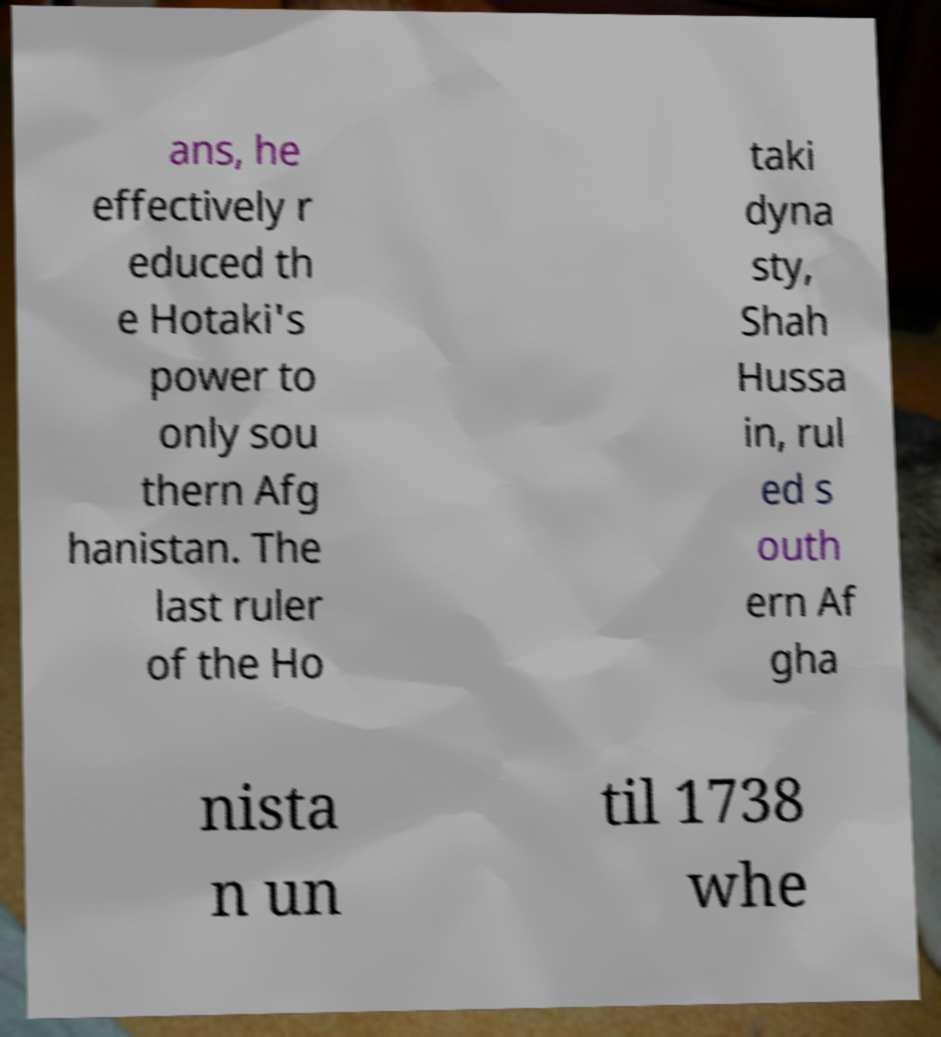I need the written content from this picture converted into text. Can you do that? ans, he effectively r educed th e Hotaki's power to only sou thern Afg hanistan. The last ruler of the Ho taki dyna sty, Shah Hussa in, rul ed s outh ern Af gha nista n un til 1738 whe 